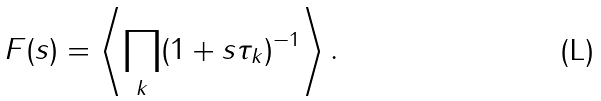Convert formula to latex. <formula><loc_0><loc_0><loc_500><loc_500>F ( s ) = \left \langle { \prod _ { k } } ( 1 + s \tau _ { k } ) ^ { - 1 } \right \rangle .</formula> 